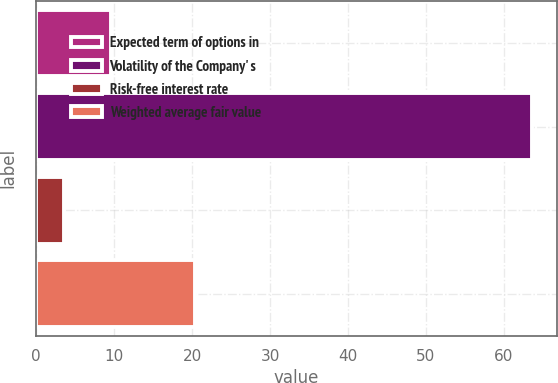<chart> <loc_0><loc_0><loc_500><loc_500><bar_chart><fcel>Expected term of options in<fcel>Volatility of the Company' s<fcel>Risk-free interest rate<fcel>Weighted average fair value<nl><fcel>9.58<fcel>63.6<fcel>3.58<fcel>20.4<nl></chart> 